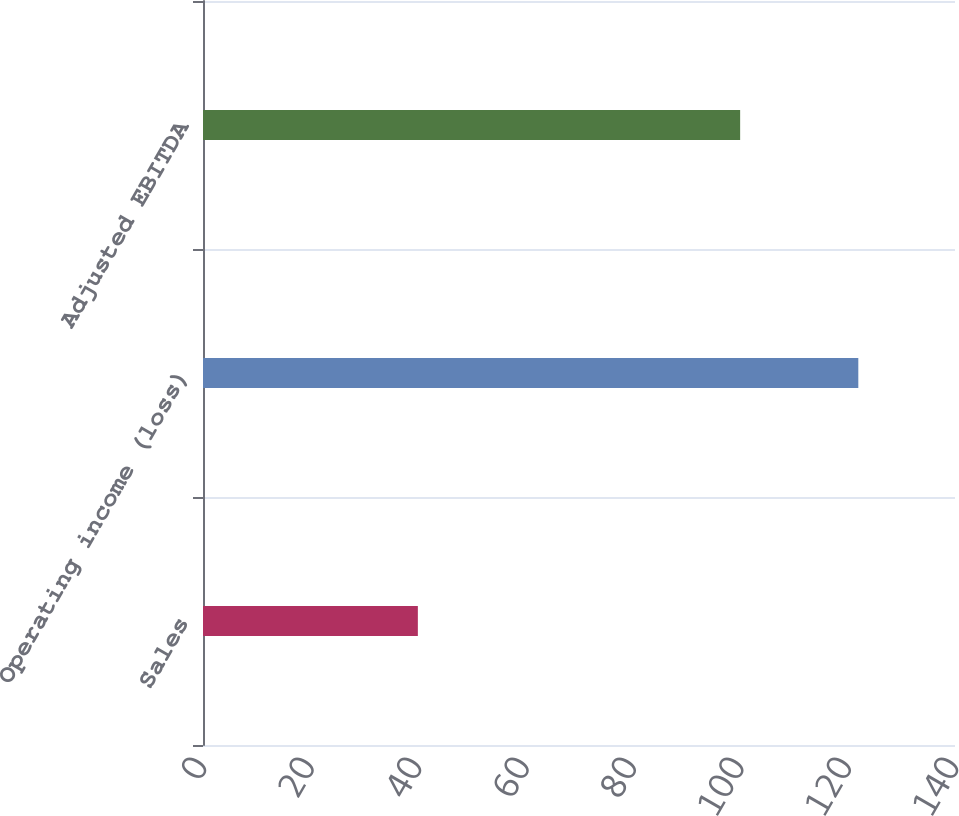Convert chart to OTSL. <chart><loc_0><loc_0><loc_500><loc_500><bar_chart><fcel>Sales<fcel>Operating income (loss)<fcel>Adjusted EBITDA<nl><fcel>40<fcel>122<fcel>100<nl></chart> 